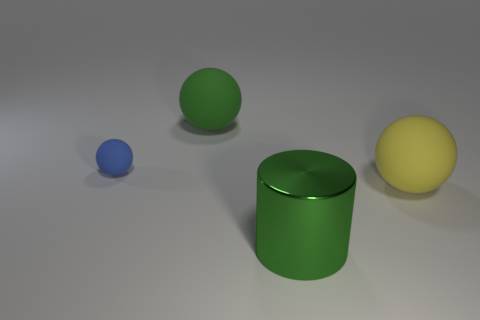How many other objects are there of the same color as the big metal object?
Your response must be concise. 1. Is the number of balls on the right side of the small blue rubber ball less than the number of green rubber balls on the right side of the large green metallic thing?
Provide a succinct answer. No. How many big cyan rubber cylinders are there?
Offer a very short reply. 0. Is there any other thing that has the same material as the large green cylinder?
Your response must be concise. No. What material is the large green object that is the same shape as the small blue thing?
Provide a succinct answer. Rubber. Are there fewer big yellow rubber spheres behind the green sphere than small blue balls?
Your response must be concise. Yes. Does the object that is in front of the yellow matte object have the same shape as the yellow object?
Your answer should be very brief. No. Are there any other things that have the same color as the large metal thing?
Your answer should be compact. Yes. There is a blue object that is the same material as the yellow ball; what is its size?
Make the answer very short. Small. What material is the green thing on the right side of the big green thing that is behind the rubber thing in front of the small blue ball?
Your response must be concise. Metal. 